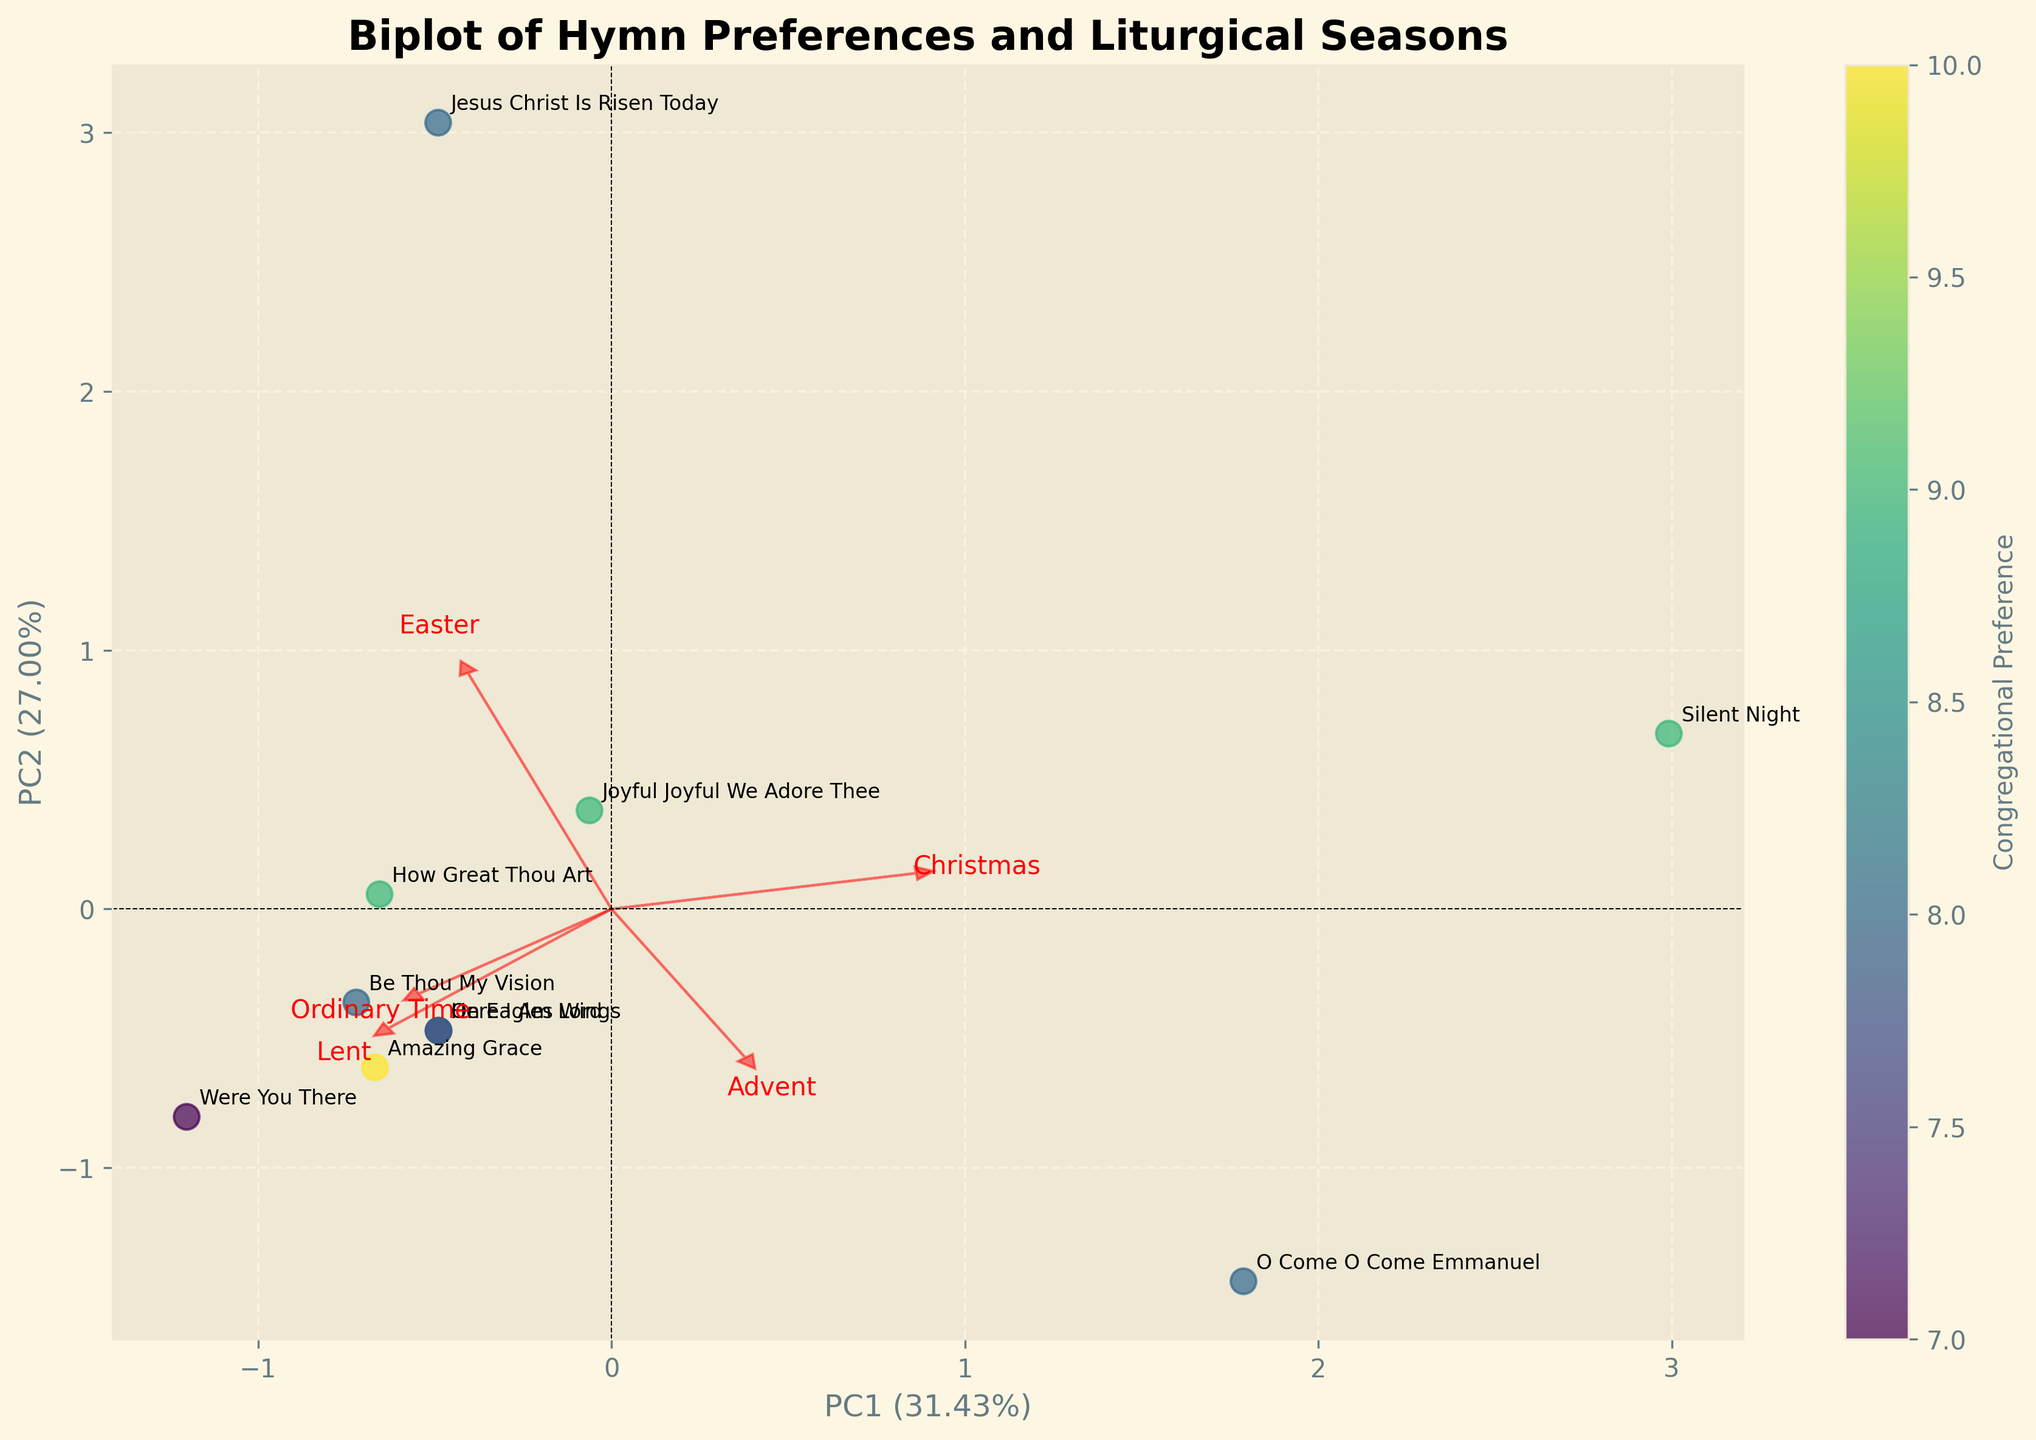What is the title of the figure? The title of the figure is mentioned at the top of the plot. By reading it, one can determine the title.
Answer: Biplot of Hymn Preferences and Liturgical Seasons How many hymns are being analyzed in the plot? Each hymn is represented by a point and associated label in the scatter plot. Counting the labels will give the total number of hymns.
Answer: 10 Which hymn has the highest congregational preference? The hue of the scatter points represents congregational preference; find the point with the darkest color close to purple.
Answer: Amazing Grace Which seasons are influencing "How Great Thou Art" most significantly according to the biplot loadings? Locate "How Great Thou Art" on the plot and observe the direction of the loadings (arrows) closest to this point.
Answer: Ordinary Time and Easter What percentage of the total variance is explained by PC1? Check the label of the x-axis where the percentage explained by PC1 is provided.
Answer: 37.84% What is the relationship between the hymns "Silent Night" and "Jesus Christ Is Risen Today" in terms of liturgical seasons? Locate both hymns on the biplot and compare their positions in relation to the arrows (loadings) representing different seasons.
Answer: Christmas and Easter Which hymn is closely associated with Advent? Find the arrow labeled "Advent" and look for the hymn labeled closest to the direction of this arrow.
Answer: O Come O Come Emmanuel In which season(s) is "Joyful Joyful We Adore Thee" moderately popular based on its position in the plot? Identify the position of "Joyful Joyful We Adore Thee" and see which arrows (liturgical seasons) are in proximity to it.
Answer: Ordinary Time and Advent How can one interpret the arrows in the biplot? The arrows represent the loadings of each original variable (liturgical seasons) on the principal components (PC1 and PC2). The length and direction indicate how strongly and in which direction these seasons affect the principal components.
Answer: They indicate direction and influence of seasons Which liturgical season shows minimal influence on the hymns "Were You There" and "Here I Am Lord"? Observe the relative positioning of these hymns in the biplot and find the arrow (season) furthest in direction away from these points.
Answer: Christmas 